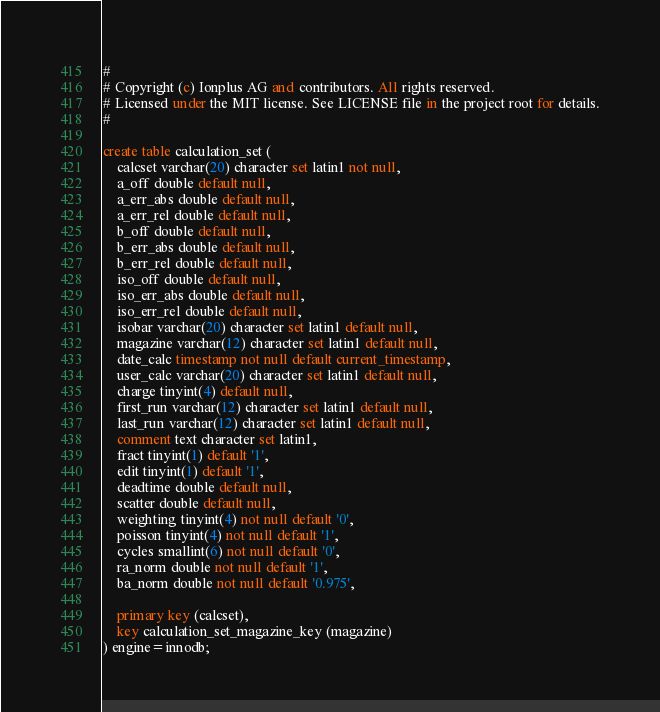<code> <loc_0><loc_0><loc_500><loc_500><_SQL_>#
# Copyright (c) Ionplus AG and contributors. All rights reserved.
# Licensed under the MIT license. See LICENSE file in the project root for details.
#

create table calculation_set (
    calcset varchar(20) character set latin1 not null,
    a_off double default null,
    a_err_abs double default null,
    a_err_rel double default null,
    b_off double default null,
    b_err_abs double default null,
    b_err_rel double default null,
    iso_off double default null,
    iso_err_abs double default null,
    iso_err_rel double default null,
    isobar varchar(20) character set latin1 default null,
    magazine varchar(12) character set latin1 default null,
    date_calc timestamp not null default current_timestamp,
    user_calc varchar(20) character set latin1 default null,
    charge tinyint(4) default null,
    first_run varchar(12) character set latin1 default null,
    last_run varchar(12) character set latin1 default null,
    comment text character set latin1,
    fract tinyint(1) default '1',
    edit tinyint(1) default '1',
    deadtime double default null,
    scatter double default null,
    weighting tinyint(4) not null default '0',
    poisson tinyint(4) not null default '1',
    cycles smallint(6) not null default '0',
    ra_norm double not null default '1',
    ba_norm double not null default '0.975',

    primary key (calcset),
    key calculation_set_magazine_key (magazine)
) engine=innodb;
</code> 